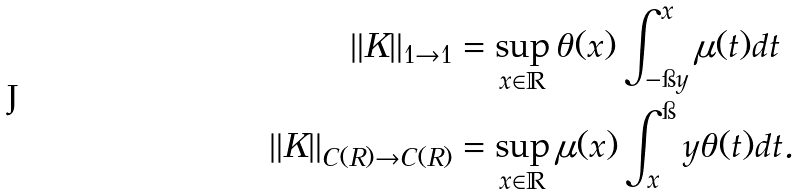<formula> <loc_0><loc_0><loc_500><loc_500>\| K \| _ { 1 \to 1 } & = \sup _ { x \in \mathbb { R } } \theta ( x ) \int _ { - \i y } ^ { x } \mu ( t ) d t \\ \| K \| _ { C ( R ) \to C ( R ) } & = \sup _ { x \in \mathbb { R } } \mu ( x ) \int _ { x } ^ { \i } y \theta ( t ) d t .</formula> 